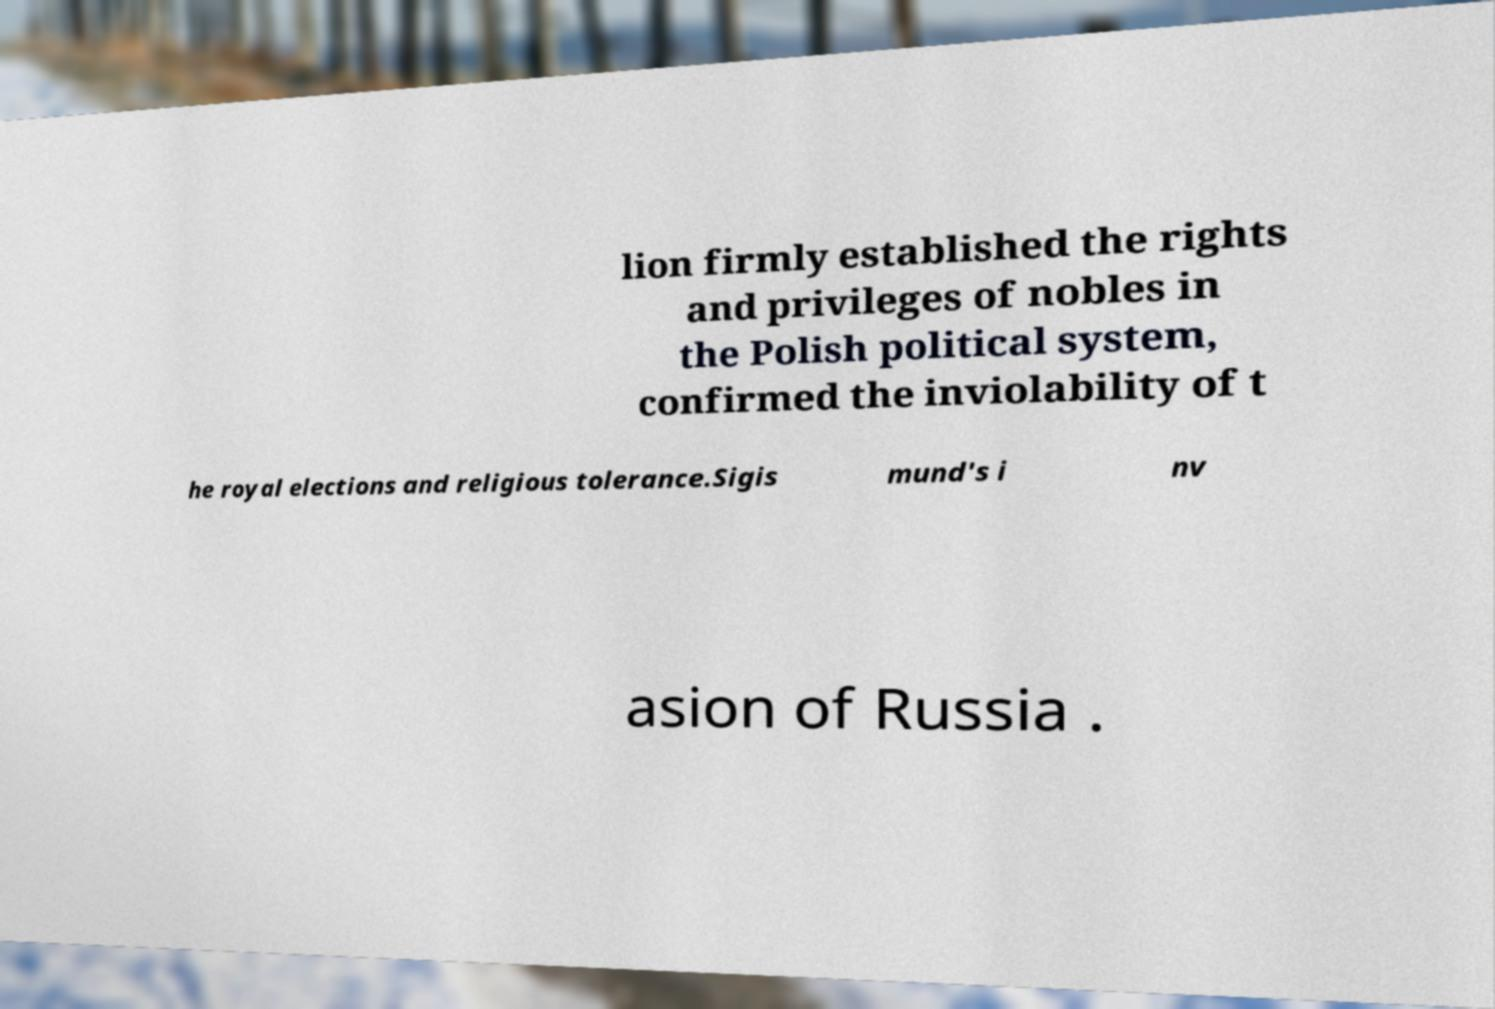Can you accurately transcribe the text from the provided image for me? lion firmly established the rights and privileges of nobles in the Polish political system, confirmed the inviolability of t he royal elections and religious tolerance.Sigis mund's i nv asion of Russia . 